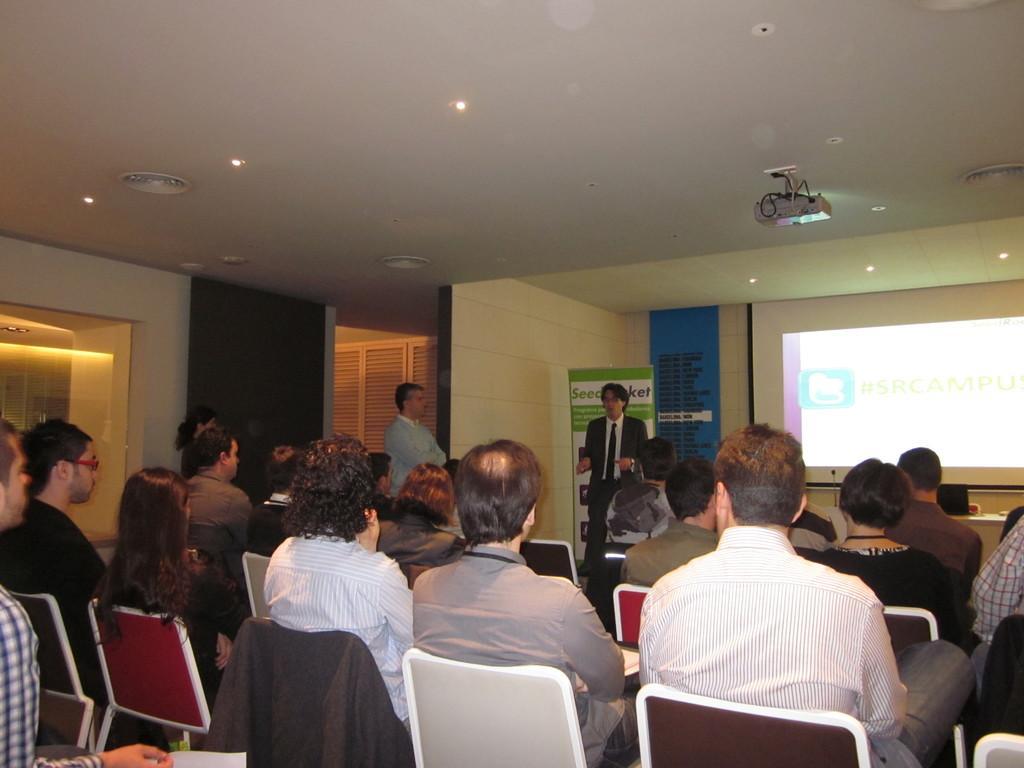Describe this image in one or two sentences. In this image I can see there are group of people sitting on chair and I can see two persons standing and I can see a screen on the right side ,at the top I can see the roof and lights visible on the roof. 